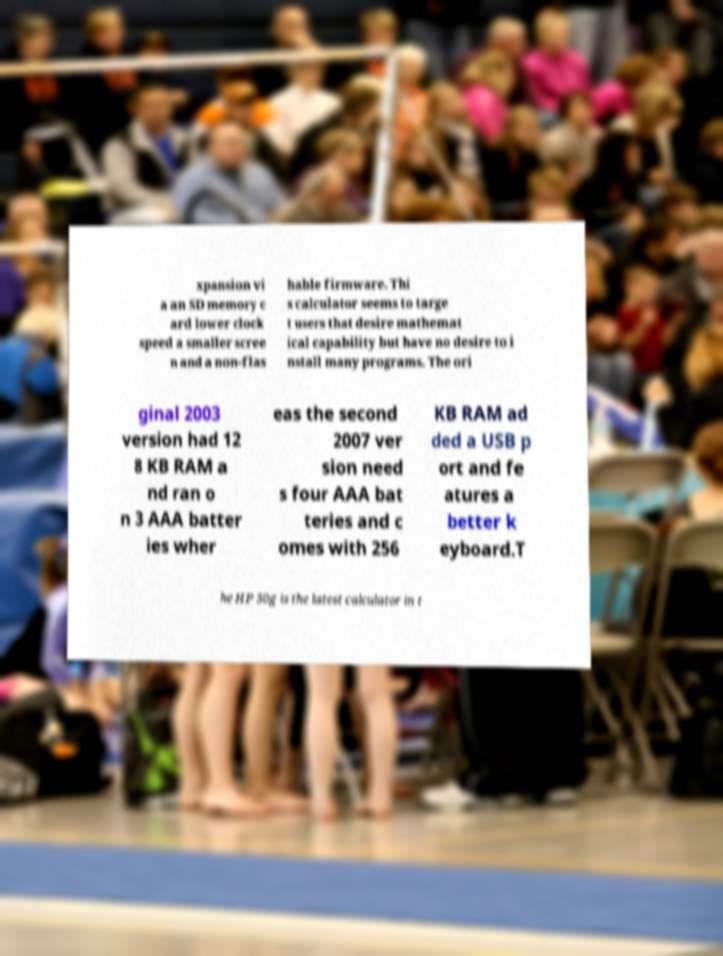Please read and relay the text visible in this image. What does it say? xpansion vi a an SD memory c ard lower clock speed a smaller scree n and a non-flas hable firmware. Thi s calculator seems to targe t users that desire mathemat ical capability but have no desire to i nstall many programs. The ori ginal 2003 version had 12 8 KB RAM a nd ran o n 3 AAA batter ies wher eas the second 2007 ver sion need s four AAA bat teries and c omes with 256 KB RAM ad ded a USB p ort and fe atures a better k eyboard.T he HP 50g is the latest calculator in t 